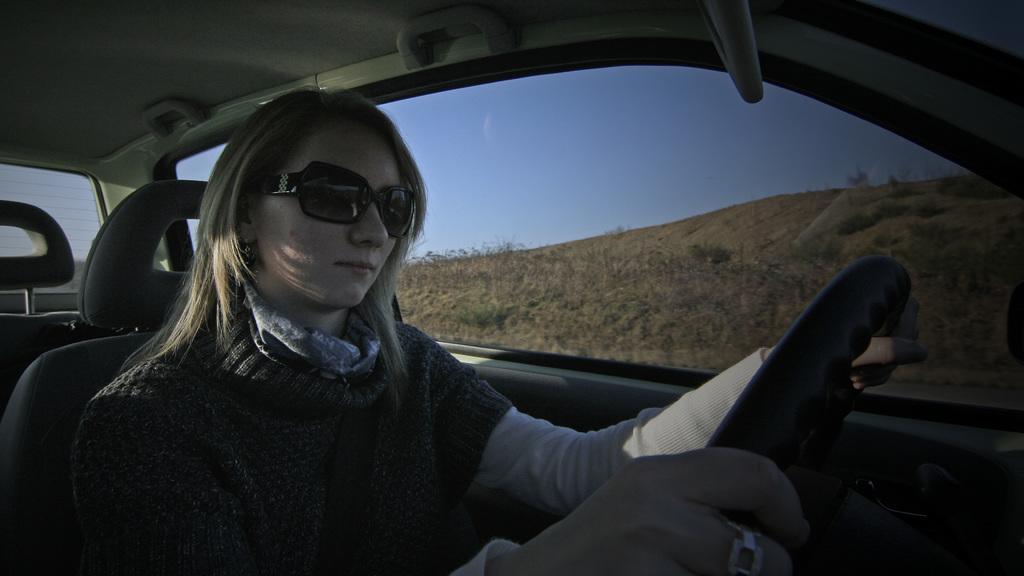Describe this image in one or two sentences. In this image I can see a woman driving her vehicle. I can also see she is wearing a black shades. In the background I can see clear view of sky. 